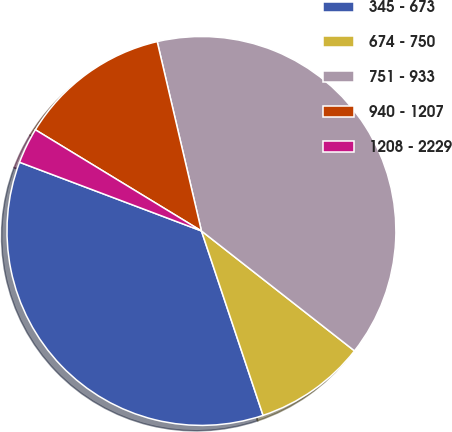Convert chart. <chart><loc_0><loc_0><loc_500><loc_500><pie_chart><fcel>345 - 673<fcel>674 - 750<fcel>751 - 933<fcel>940 - 1207<fcel>1208 - 2229<nl><fcel>35.88%<fcel>9.29%<fcel>39.23%<fcel>12.64%<fcel>2.96%<nl></chart> 